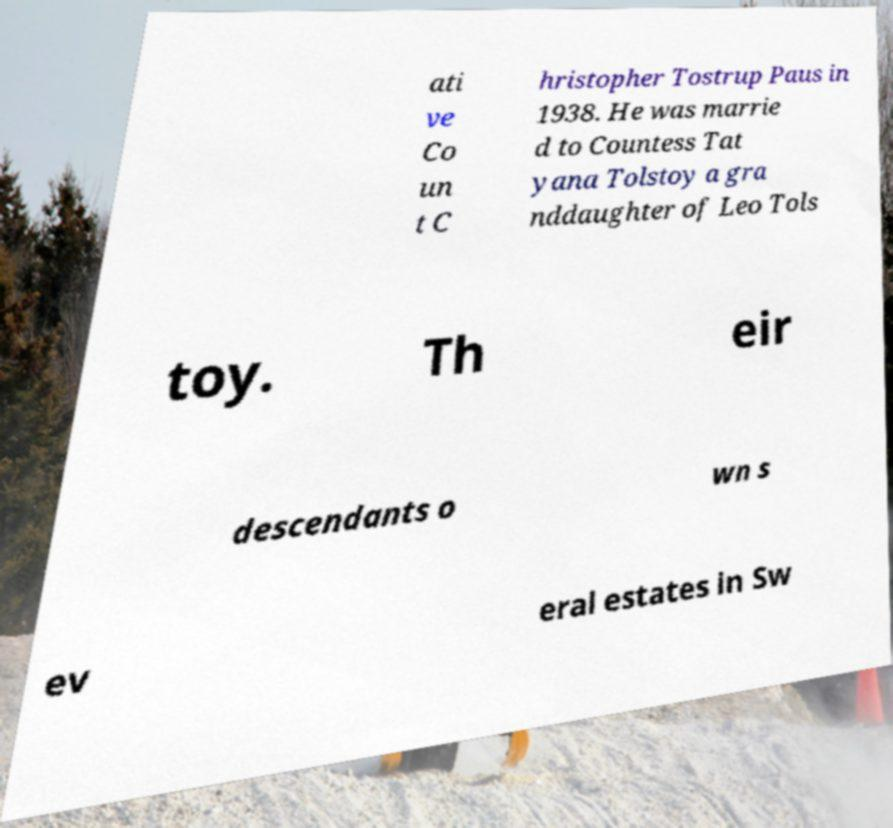I need the written content from this picture converted into text. Can you do that? ati ve Co un t C hristopher Tostrup Paus in 1938. He was marrie d to Countess Tat yana Tolstoy a gra nddaughter of Leo Tols toy. Th eir descendants o wn s ev eral estates in Sw 